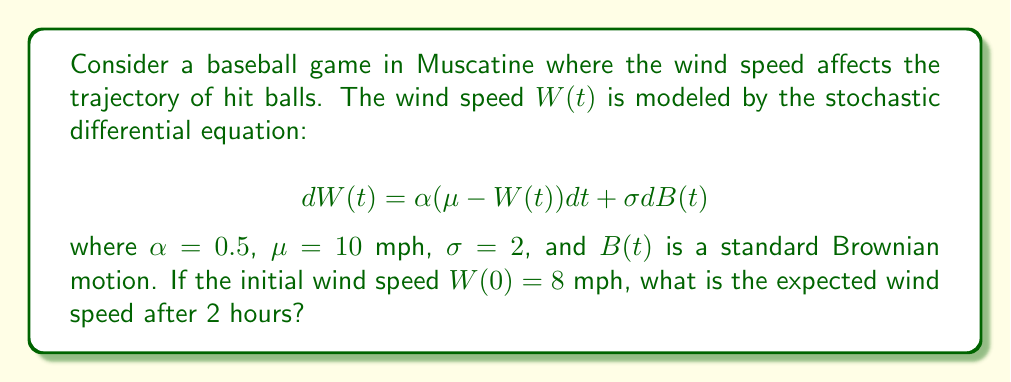Show me your answer to this math problem. To solve this problem, we'll use the properties of the Ornstein-Uhlenbeck process, which is described by the given stochastic differential equation.

1) The Ornstein-Uhlenbeck process has the following expected value at time t:

   $$E[W(t)] = \mu + (W(0) - \mu)e^{-\alpha t}$$

2) Let's substitute the given values:
   $\alpha = 0.5$
   $\mu = 10$ mph
   $W(0) = 8$ mph
   $t = 2$ hours

3) Plugging these into the formula:

   $$E[W(2)] = 10 + (8 - 10)e^{-0.5 \cdot 2}$$

4) Simplify:
   $$E[W(2)] = 10 - 2e^{-1}$$

5) Calculate:
   $$E[W(2)] = 10 - 2 \cdot 0.3679 = 10 - 0.7358 = 9.2642$$

Therefore, the expected wind speed after 2 hours is approximately 9.26 mph.
Answer: 9.26 mph 